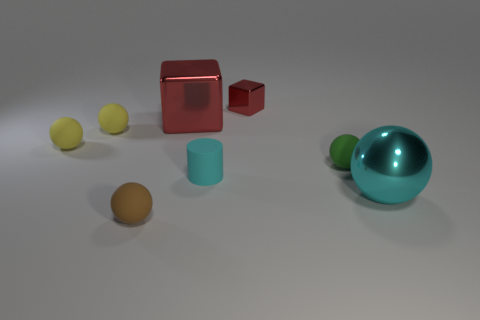Is the big red block made of the same material as the tiny block?
Offer a very short reply. Yes. How many other objects are the same size as the brown sphere?
Ensure brevity in your answer.  5. The cylinder on the left side of the tiny cube that is behind the cyan matte object is what color?
Provide a succinct answer. Cyan. What number of other things are the same shape as the tiny cyan thing?
Offer a terse response. 0. Is there a small cyan cylinder that has the same material as the green sphere?
Give a very brief answer. Yes. There is a cube that is the same size as the green rubber sphere; what material is it?
Provide a short and direct response. Metal. The tiny rubber sphere that is right of the matte object in front of the cyan thing that is in front of the cyan rubber thing is what color?
Make the answer very short. Green. There is a big metal thing that is left of the small green rubber object; does it have the same shape as the red metal thing that is right of the large block?
Provide a succinct answer. Yes. How many large purple cubes are there?
Ensure brevity in your answer.  0. What is the color of the metallic object that is the same size as the cyan metallic ball?
Provide a short and direct response. Red. 